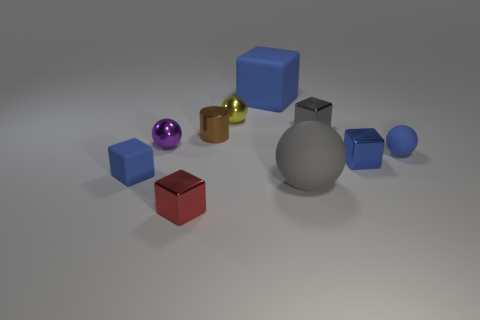What is the material of the small object that is in front of the purple shiny thing and left of the red block?
Provide a succinct answer. Rubber. Are there an equal number of blue matte blocks in front of the red metal thing and metallic cylinders?
Offer a very short reply. No. What number of things are either matte objects that are in front of the small matte sphere or large cyan shiny cubes?
Give a very brief answer. 2. There is a tiny block that is left of the tiny red object; is its color the same as the tiny matte ball?
Keep it short and to the point. Yes. There is a blue matte thing that is behind the small yellow object; how big is it?
Provide a short and direct response. Large. What is the shape of the large matte thing that is behind the tiny blue rubber thing to the left of the small shiny cylinder?
Provide a succinct answer. Cube. What is the color of the other shiny thing that is the same shape as the yellow metallic object?
Your answer should be very brief. Purple. Is the size of the blue block right of the gray sphere the same as the small blue ball?
Give a very brief answer. Yes. What is the shape of the small metallic object that is the same color as the big matte sphere?
Ensure brevity in your answer.  Cube. What number of cubes have the same material as the red object?
Offer a terse response. 2. 